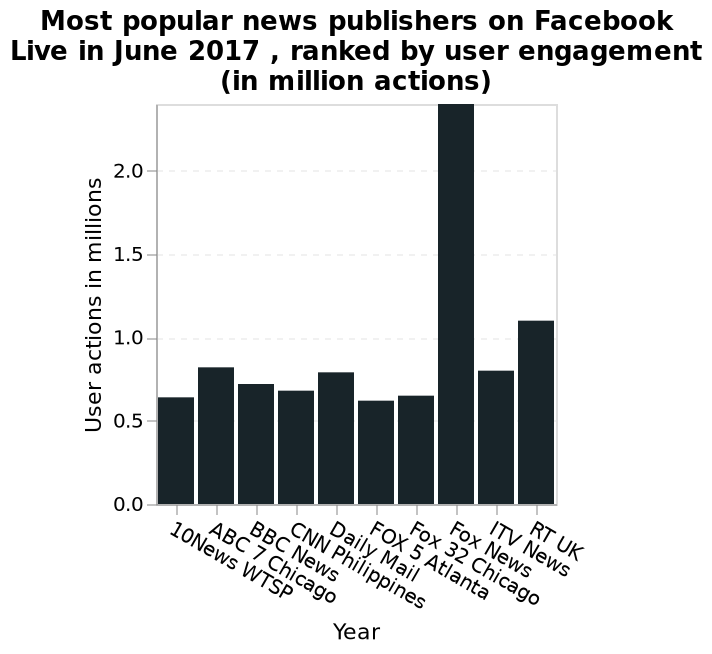<image>
What is the time period covered by the data presented in the bar plot? The data presented in the bar plot is for the month of June 2017. 